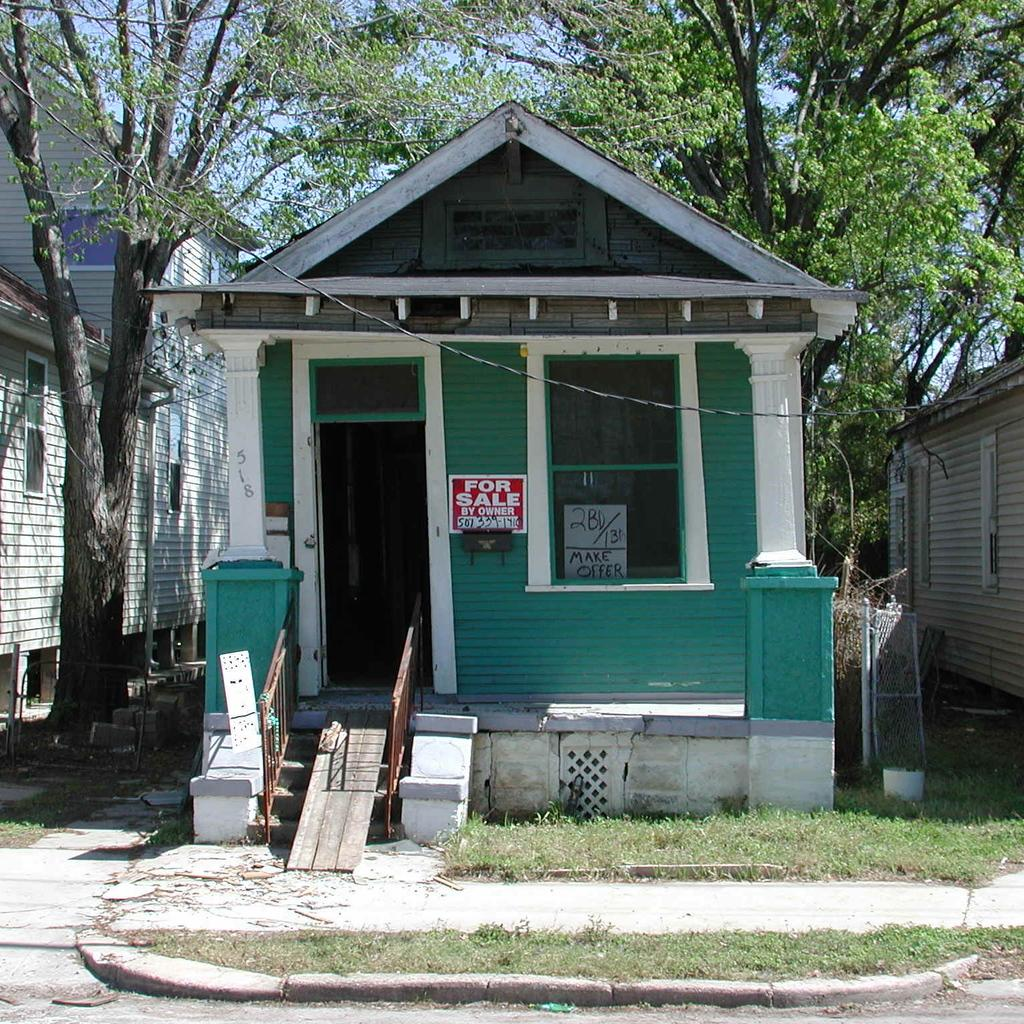What type of band can be seen playing in the image? There is no band present in the image. Can you describe the thumb in the image? There is no thumb visible in the image. What is the size of the houses in the image? The size of the houses cannot be determined from the image alone, as there is no reference for scale. What type of music is the band playing in the image? There is no band present in the image, so it is not possible to determine the type of music being played. 